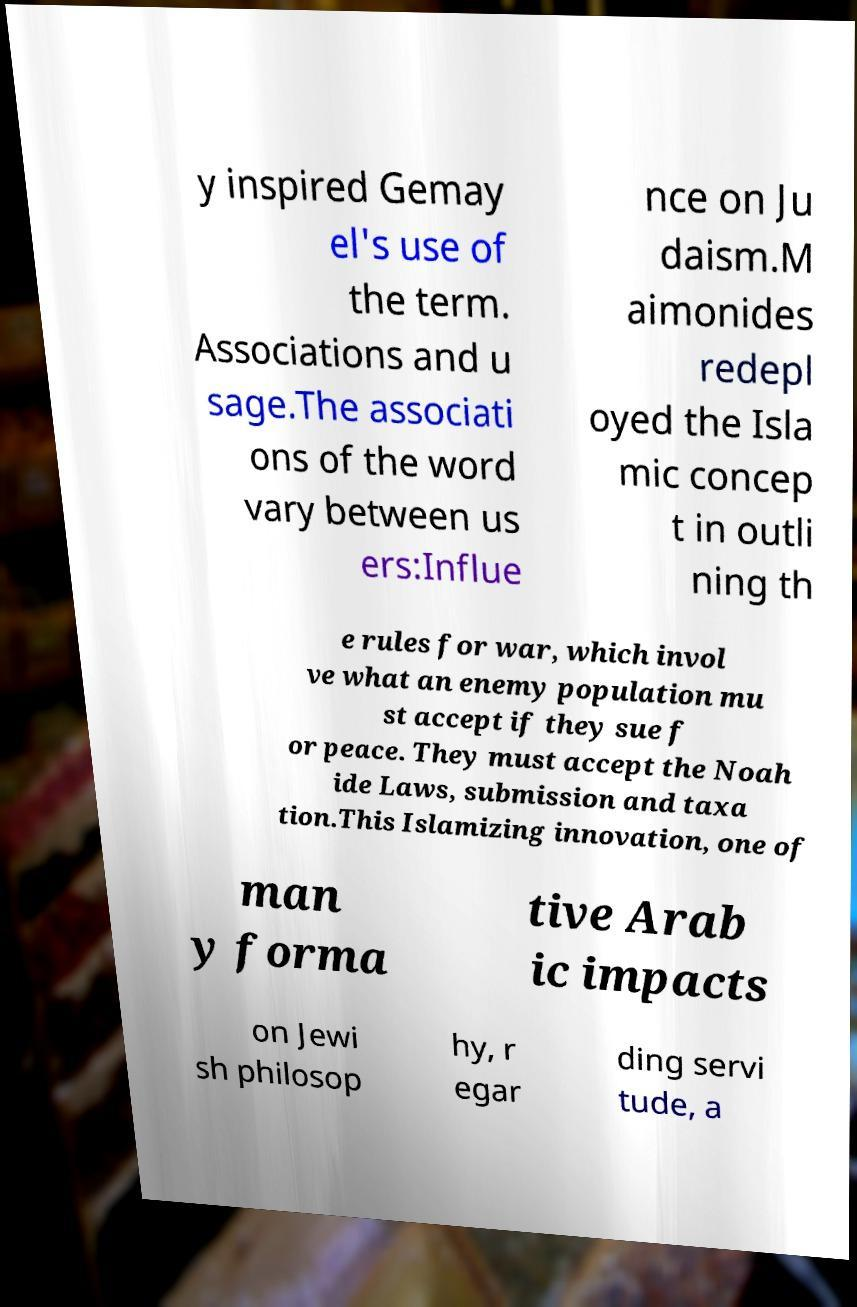Can you accurately transcribe the text from the provided image for me? y inspired Gemay el's use of the term. Associations and u sage.The associati ons of the word vary between us ers:Influe nce on Ju daism.M aimonides redepl oyed the Isla mic concep t in outli ning th e rules for war, which invol ve what an enemy population mu st accept if they sue f or peace. They must accept the Noah ide Laws, submission and taxa tion.This Islamizing innovation, one of man y forma tive Arab ic impacts on Jewi sh philosop hy, r egar ding servi tude, a 